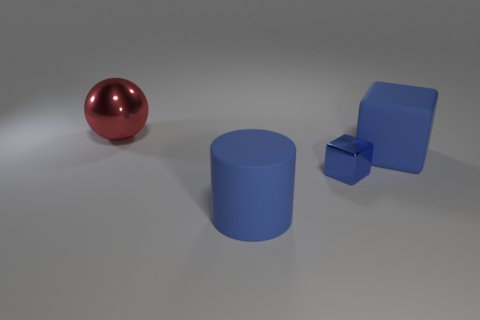Does the big matte block have the same color as the shiny block?
Your answer should be very brief. Yes. What is the material of the large blue object right of the metallic thing that is in front of the red shiny thing that is behind the big blue cylinder?
Keep it short and to the point. Rubber. Are there any blue blocks right of the small metallic cube?
Offer a terse response. Yes. What shape is the metal object that is the same size as the rubber block?
Provide a short and direct response. Sphere. Are the large blue cylinder and the tiny object made of the same material?
Your response must be concise. No. How many metallic objects are big blue cylinders or small cyan objects?
Your answer should be compact. 0. There is a large object that is the same color as the large rubber cube; what is its shape?
Ensure brevity in your answer.  Cylinder. Is the color of the matte thing behind the blue metal object the same as the small cube?
Offer a terse response. Yes. There is a thing that is on the left side of the big object in front of the small blue object; what shape is it?
Give a very brief answer. Sphere. How many objects are either cylinders that are on the left side of the tiny thing or things in front of the tiny metallic block?
Offer a terse response. 1. 